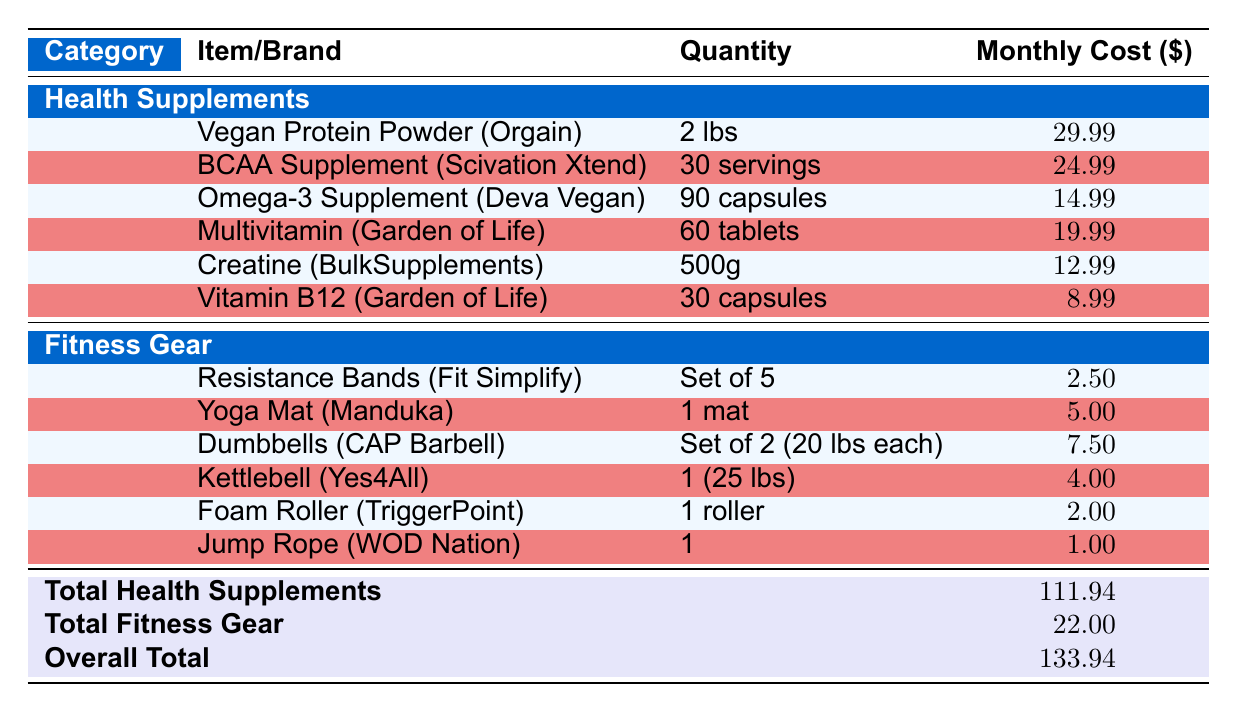What is the monthly cost of the Vegan Protein Powder? The table lists the Vegan Protein Powder under Health Supplements with a monthly cost of 29.99 USD.
Answer: 29.99 Which item from the Fitness Gear category has the lowest monthly cost? In the Fitness Gear section, the Jump Rope is listed with a monthly cost of 1.00 USD, which is lower than all other items in this category.
Answer: Jump Rope What is the total monthly cost of all Health Supplements? The table provides a total of 111.94 USD for Health Supplements, calculated by summing the individual costs of all items in that category.
Answer: 111.94 Do any Health Supplements exceed a monthly cost of 25 USD? Examining the costs, the Vegan Protein Powder (29.99) and BCAA Supplement (24.99) are the only items checked, and indeed, the Vegan Protein Powder exceeds 25 USD while the BCAA does not.
Answer: Yes What is the combined monthly cost of the Kettlebell and Dumbbells? The cost of the Kettlebell is 4.00 USD, and the Dumbbells are 7.50 USD. Adding these together, 4.00 + 7.50 gives 11.50 USD.
Answer: 11.50 If you were to exclude the Omega-3 Supplement, what would be the new total monthly cost for Health Supplements? The original total is 111.94 USD. Subtracting the Omega-3 Supplement cost (14.99), we calculate 111.94 - 14.99 = 96.95 USD.
Answer: 96.95 Is the total cost of Fitness Gear greater than 20 USD? The table shows the total for Fitness Gear as 22.00 USD, confirming it is indeed greater than 20 USD.
Answer: Yes What is the average monthly cost of the three most expensive Health Supplements? Identifying the three most costly items: Vegan Protein Powder (29.99), BCAA Supplement (24.99), and Multivitamin (19.99), we sum them to get 29.99 + 24.99 + 19.99 = 74.97 USD. Dividing by 3 gives the average of 24.99 USD.
Answer: 24.99 